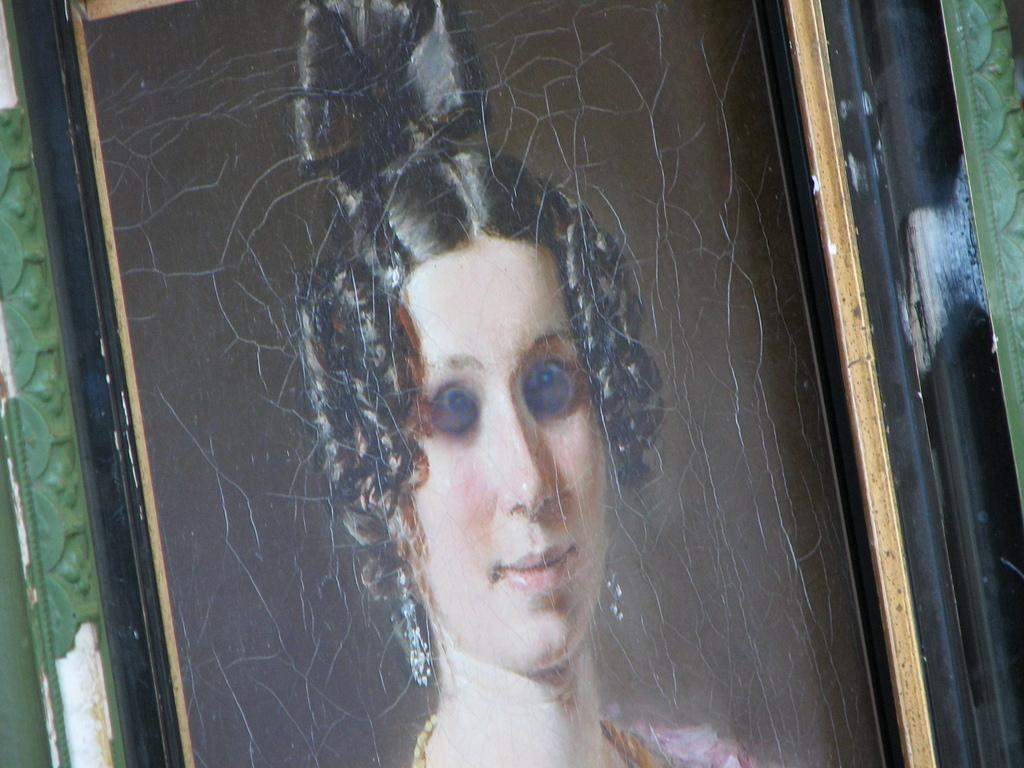What is the main subject of the image? There is a frame of a person in the image. What type of powder is being used by the governor in the image? There is no governor or powder present in the image; it only features a frame of a person. 